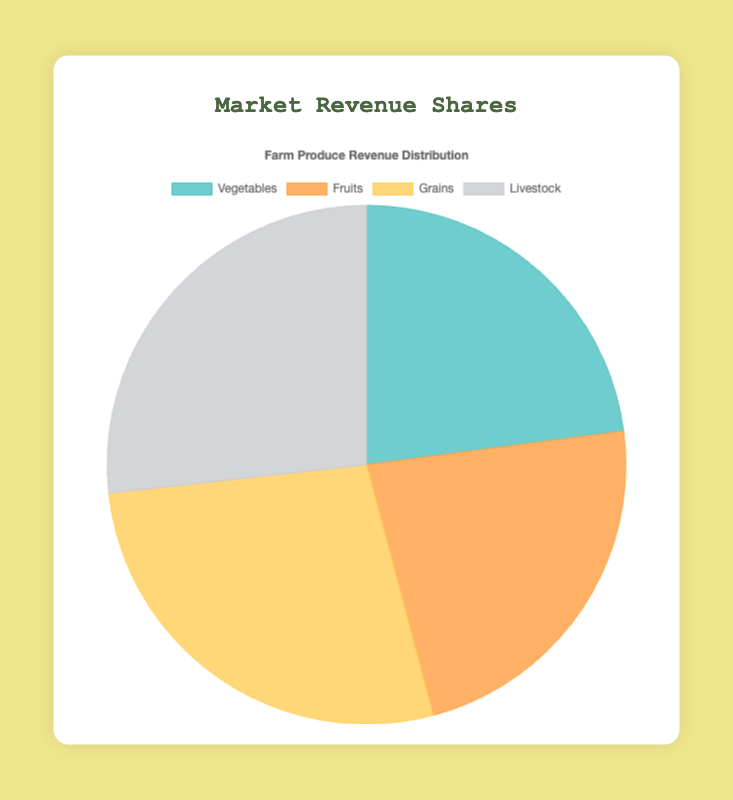What produce category has the highest market revenue share? The Livestock category has the highest market revenue share because its corresponding section of the pie chart is the largest slice visually.
Answer: Livestock How much do Fruits and Vegetables contribute to the market revenue together? The Vegetables contribute 36% and the Fruits contribute 36%. Their combined contribution is 36% + 36% = 72%.
Answer: 72% Which category has the lowest revenue share and what is its percentage? The Vegetables and Fruits categories are tied with the smallest segments in the pie chart, each representing 36%.
Answer: Vegetables and Fruits, 36% How does the revenue share of Grains compare to that of Livestock? Grains have a revenue share of 43%, while Livestock has a revenue share of 42%. 43% is slightly higher than 42%, so Grains have a larger share.
Answer: Grains have a slightly larger share Which two categories together make up over half of the market revenue share? Examining the pie chart, the Grains (43%) and Livestock (42%) categories together account for 43% + 42% = 85%, which is more than half of the total revenue share.
Answer: Grains and Livestock What is the average revenue share percentage across all categories? Sum the percentages for all categories: 36% (Vegetables) + 36% (Fruits) + 43% (Grains) + 42% (Livestock) = 157%. Divide this by 4 categories, so 157% / 4 = 39.25%.
Answer: 39.25% What are the visual colors representing Vegetables and Livestock categories in the pie chart? The color representing Vegetables is a shade of green, and the color representing Livestock is a shade of gray. These colors are visually distinct in the pie chart.
Answer: Green and gray Is the market revenue share of Fruits equal to that of Vegetables? Both Fruits and Vegetables contribute equally to the market revenue share, each accounting for 36%.
Answer: Yes, they are equal What is the difference in percentage points between the market shares of Vegetables and Grains? The Vegetables category is 36% and the Grains category is 43%. The difference is 43% - 36% = 7 percentage points.
Answer: 7 percentage points How does the combined share of Vegetables, Grains, and Livestock compare to that of Fruits alone? The combined share of Vegetables (36%), Grains (43%), and Livestock (42%) is 36% + 43% + 42% = 121%. The Fruits share alone is 36%. Hence, the combined share is significantly larger.
Answer: Combined share is significantly larger 